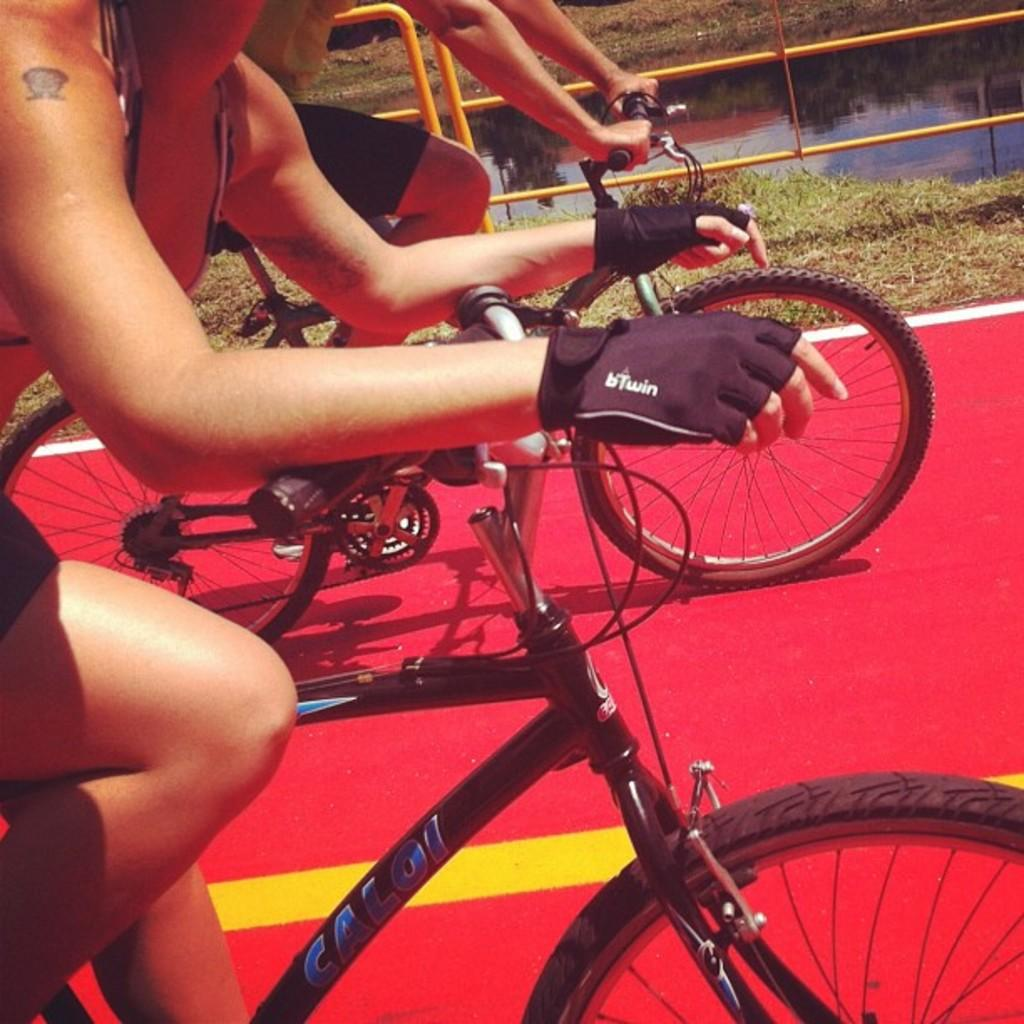What are the two people in the image doing? There is a man and a woman riding bicycles in the image. What can be seen on the ground in the image? The ground is visible in the image. What type of barrier is present in the image? There is a fence in the image. What type of vegetation is present in the image? Grass is present in the image. What else can be seen in the image besides the people and the fence? There is water visible in the image. What type of soup is being served in the image? There is no soup present in the image; it features a man and a woman riding bicycles. How does the bee interact with the water in the image? There is no bee present in the image; it only features a man and a woman riding bicycles, the ground, a fence, grass, and water. 